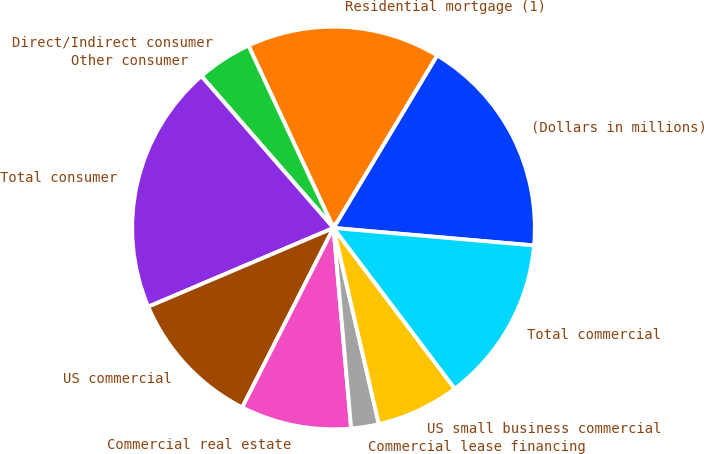Convert chart to OTSL. <chart><loc_0><loc_0><loc_500><loc_500><pie_chart><fcel>(Dollars in millions)<fcel>Residential mortgage (1)<fcel>Direct/Indirect consumer<fcel>Other consumer<fcel>Total consumer<fcel>US commercial<fcel>Commercial real estate<fcel>Commercial lease financing<fcel>US small business commercial<fcel>Total commercial<nl><fcel>17.78%<fcel>15.55%<fcel>4.45%<fcel>0.0%<fcel>20.0%<fcel>11.11%<fcel>8.89%<fcel>2.22%<fcel>6.67%<fcel>13.33%<nl></chart> 